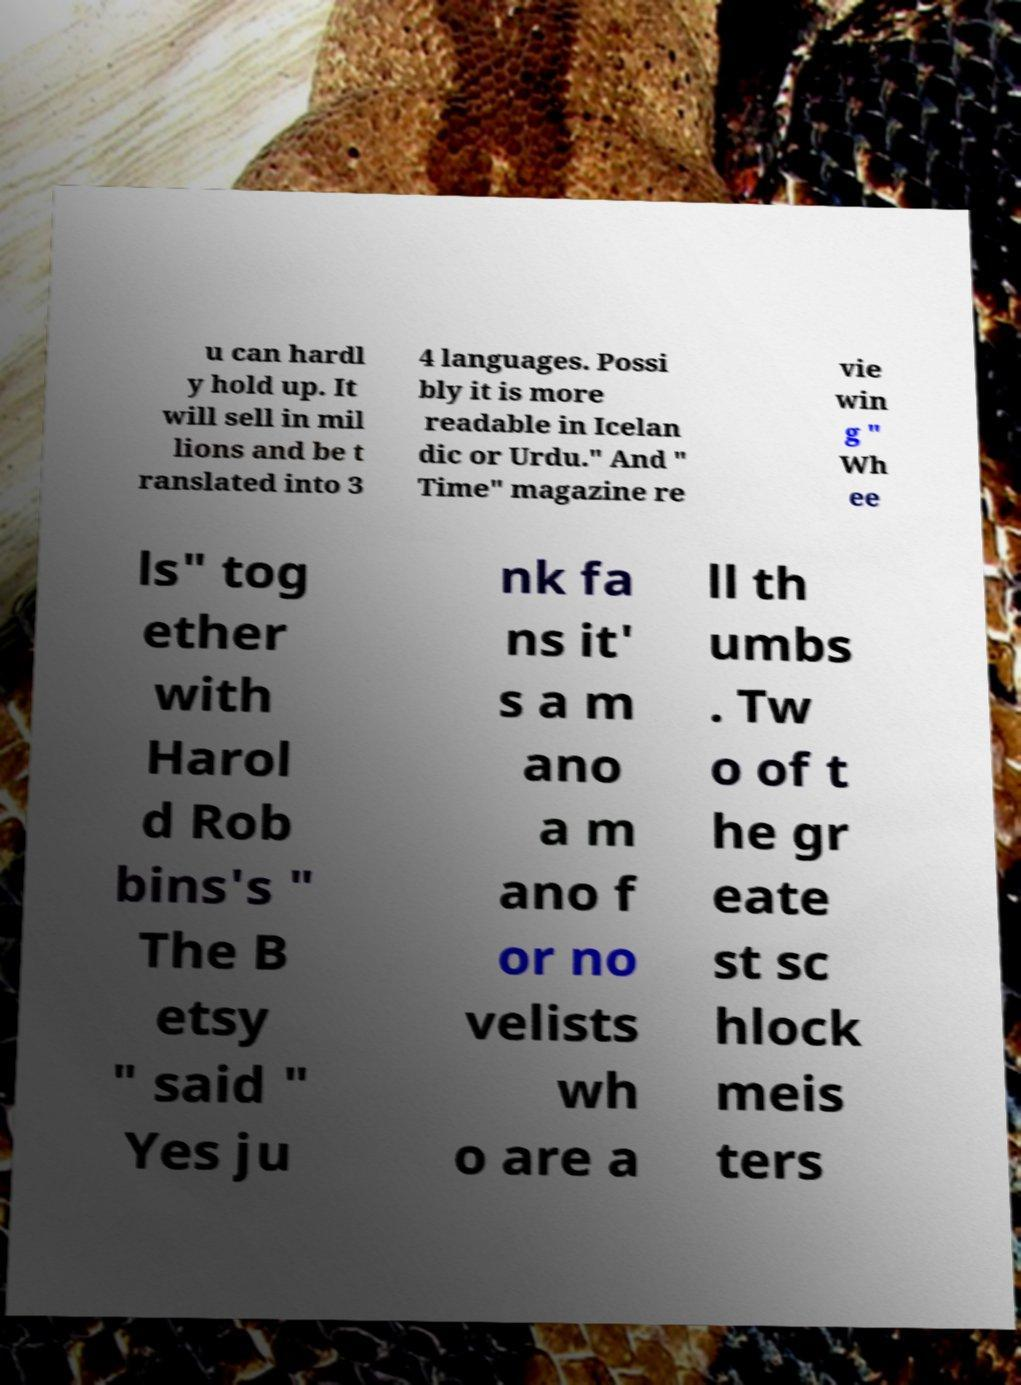Could you extract and type out the text from this image? u can hardl y hold up. It will sell in mil lions and be t ranslated into 3 4 languages. Possi bly it is more readable in Icelan dic or Urdu." And " Time" magazine re vie win g " Wh ee ls" tog ether with Harol d Rob bins's " The B etsy " said " Yes ju nk fa ns it' s a m ano a m ano f or no velists wh o are a ll th umbs . Tw o of t he gr eate st sc hlock meis ters 